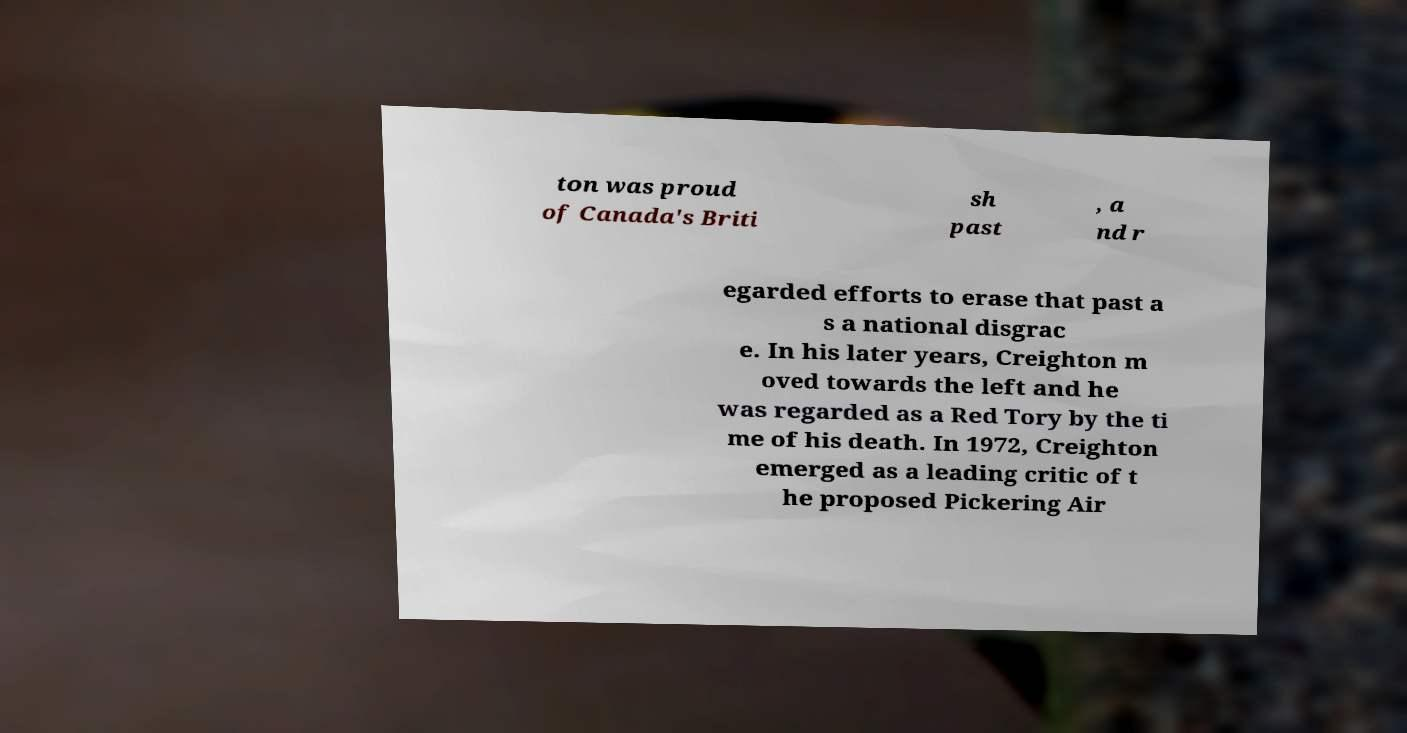Can you read and provide the text displayed in the image?This photo seems to have some interesting text. Can you extract and type it out for me? ton was proud of Canada's Briti sh past , a nd r egarded efforts to erase that past a s a national disgrac e. In his later years, Creighton m oved towards the left and he was regarded as a Red Tory by the ti me of his death. In 1972, Creighton emerged as a leading critic of t he proposed Pickering Air 